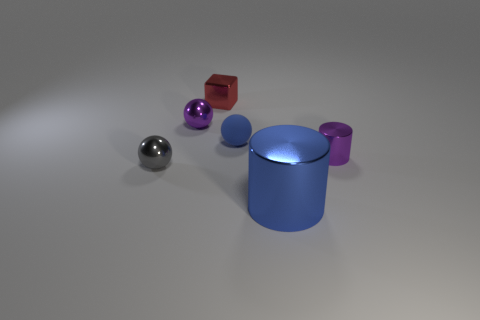Does the small rubber ball have the same color as the metallic object that is in front of the tiny gray metallic ball?
Your answer should be very brief. Yes. What is the shape of the large shiny object that is the same color as the small rubber thing?
Ensure brevity in your answer.  Cylinder. The metallic cylinder that is the same color as the rubber sphere is what size?
Offer a very short reply. Large. Is the rubber ball the same size as the blue cylinder?
Your response must be concise. No. How many other objects are there of the same shape as the large blue thing?
Offer a very short reply. 1. What is the material of the ball that is on the right side of the purple metal thing on the left side of the small red metal object?
Make the answer very short. Rubber. There is a gray metallic thing; are there any small objects right of it?
Offer a very short reply. Yes. There is a gray shiny sphere; is it the same size as the purple object on the left side of the block?
Your answer should be very brief. Yes. What is the size of the purple metal object that is the same shape as the small blue matte thing?
Your answer should be compact. Small. Is there any other thing that has the same material as the blue ball?
Offer a very short reply. No. 